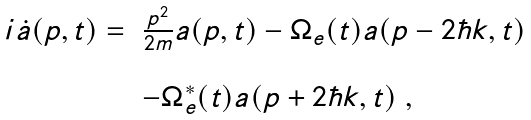<formula> <loc_0><loc_0><loc_500><loc_500>\begin{array} { l l l } i \dot { a } ( p , t ) = & \frac { p ^ { 2 } } { 2 m } a ( p , t ) - \Omega _ { e } ( t ) a ( p - 2 \hbar { k } , t ) & \\ & \, & \\ & - \Omega _ { e } ^ { * } ( t ) a ( p + 2 \hbar { k } , t ) \ , \end{array}</formula> 